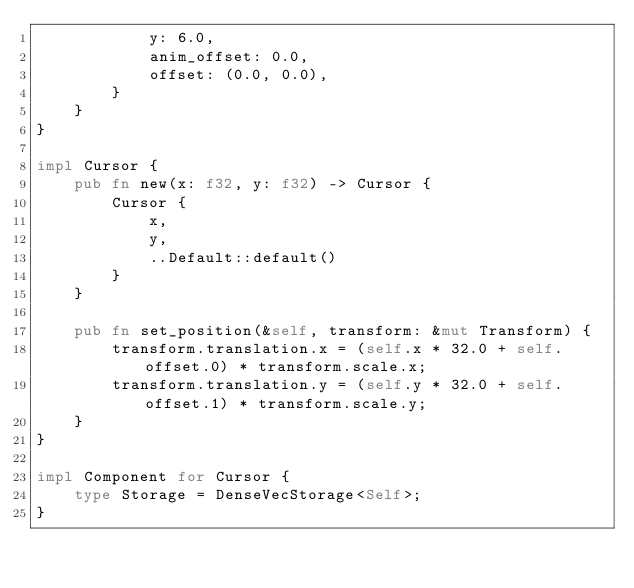Convert code to text. <code><loc_0><loc_0><loc_500><loc_500><_Rust_>            y: 6.0,
            anim_offset: 0.0,
            offset: (0.0, 0.0),
        }
    }
}

impl Cursor {
    pub fn new(x: f32, y: f32) -> Cursor {
        Cursor {
            x,
            y,
            ..Default::default()
        }
    }

    pub fn set_position(&self, transform: &mut Transform) {
        transform.translation.x = (self.x * 32.0 + self.offset.0) * transform.scale.x;
        transform.translation.y = (self.y * 32.0 + self.offset.1) * transform.scale.y;
    }
}

impl Component for Cursor {
    type Storage = DenseVecStorage<Self>;
}
</code> 